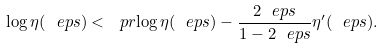Convert formula to latex. <formula><loc_0><loc_0><loc_500><loc_500>\log \eta ( \ e p s ) < \ p r { \log \eta ( \ e p s ) - \frac { 2 \ e p s } { 1 - 2 \ e p s } } \eta ^ { \prime } ( \ e p s ) .</formula> 